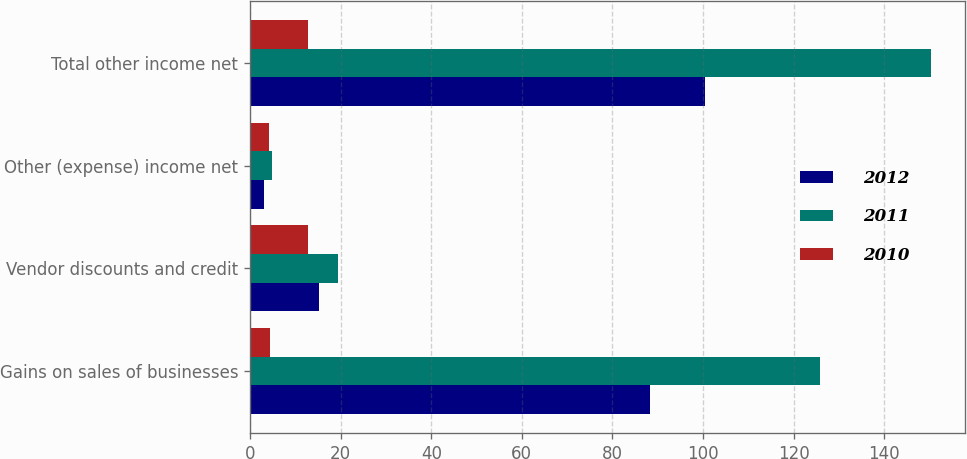Convert chart to OTSL. <chart><loc_0><loc_0><loc_500><loc_500><stacked_bar_chart><ecel><fcel>Gains on sales of businesses<fcel>Vendor discounts and credit<fcel>Other (expense) income net<fcel>Total other income net<nl><fcel>2012<fcel>88.2<fcel>15.3<fcel>3<fcel>100.5<nl><fcel>2011<fcel>125.9<fcel>19.4<fcel>4.9<fcel>150.2<nl><fcel>2010<fcel>4.3<fcel>12.7<fcel>4.1<fcel>12.9<nl></chart> 